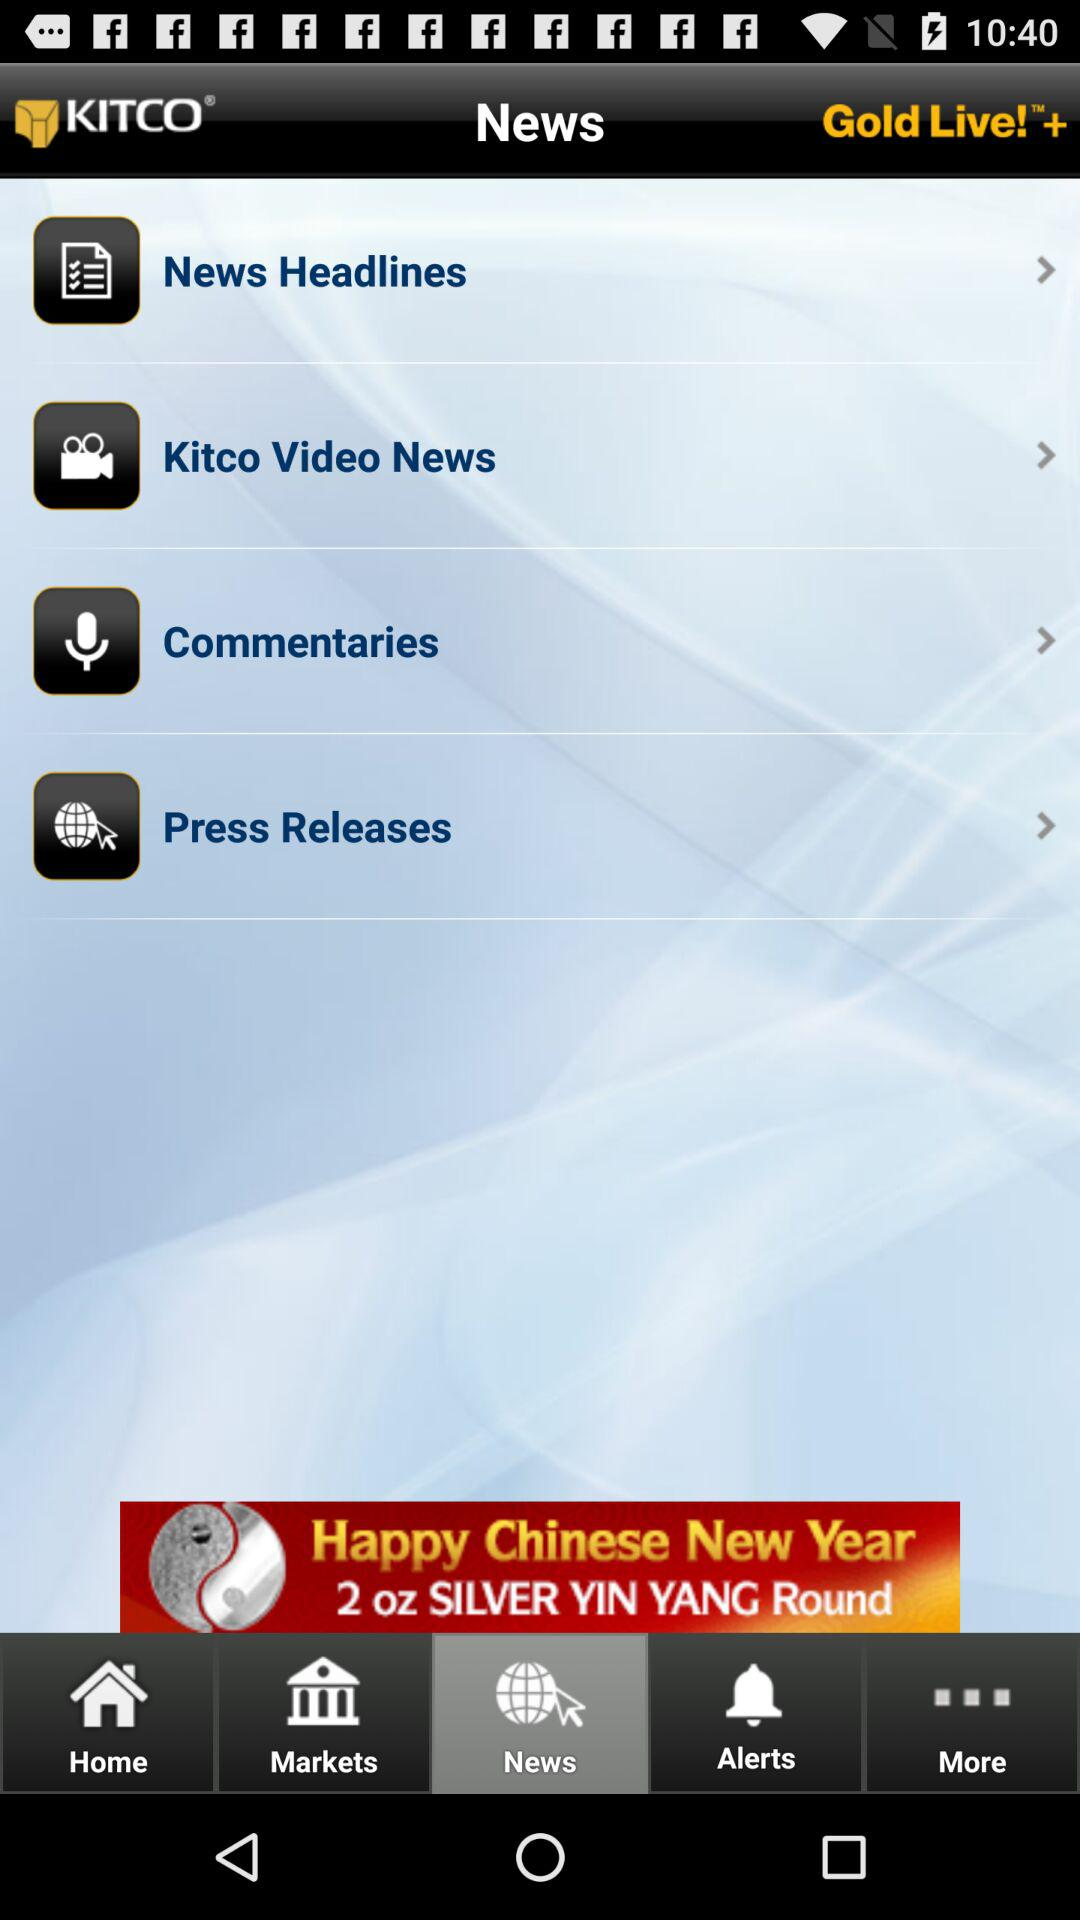When was the last press release?
When the provided information is insufficient, respond with <no answer>. <no answer> 